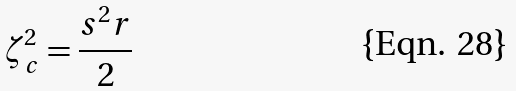Convert formula to latex. <formula><loc_0><loc_0><loc_500><loc_500>\zeta ^ { 2 } _ { c } = \frac { s ^ { 2 } r } { 2 }</formula> 